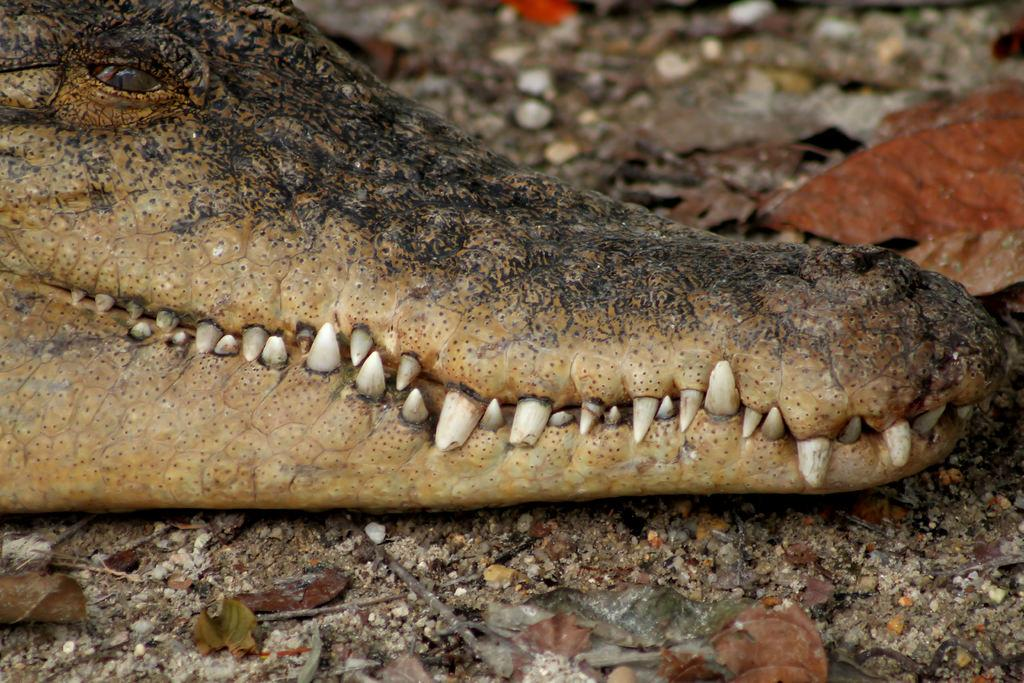What is the main subject of the image? The main subject of the image is a brown crocodile face. What is the position of the crocodile face in the image? The crocodile face is lying on the ground. What can be seen behind the crocodile face in the image? There is a brown dry leaf behind the crocodile face. What type of advertisement is being displayed on the crocodile face in the image? There is no advertisement present on the crocodile face in the image. 